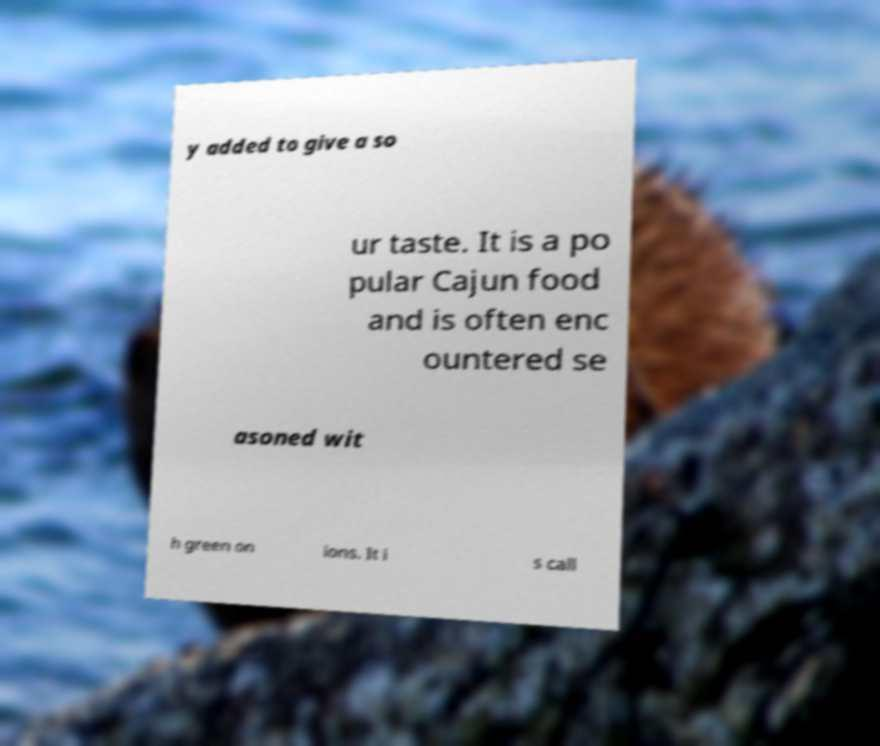Can you read and provide the text displayed in the image?This photo seems to have some interesting text. Can you extract and type it out for me? y added to give a so ur taste. It is a po pular Cajun food and is often enc ountered se asoned wit h green on ions. It i s call 